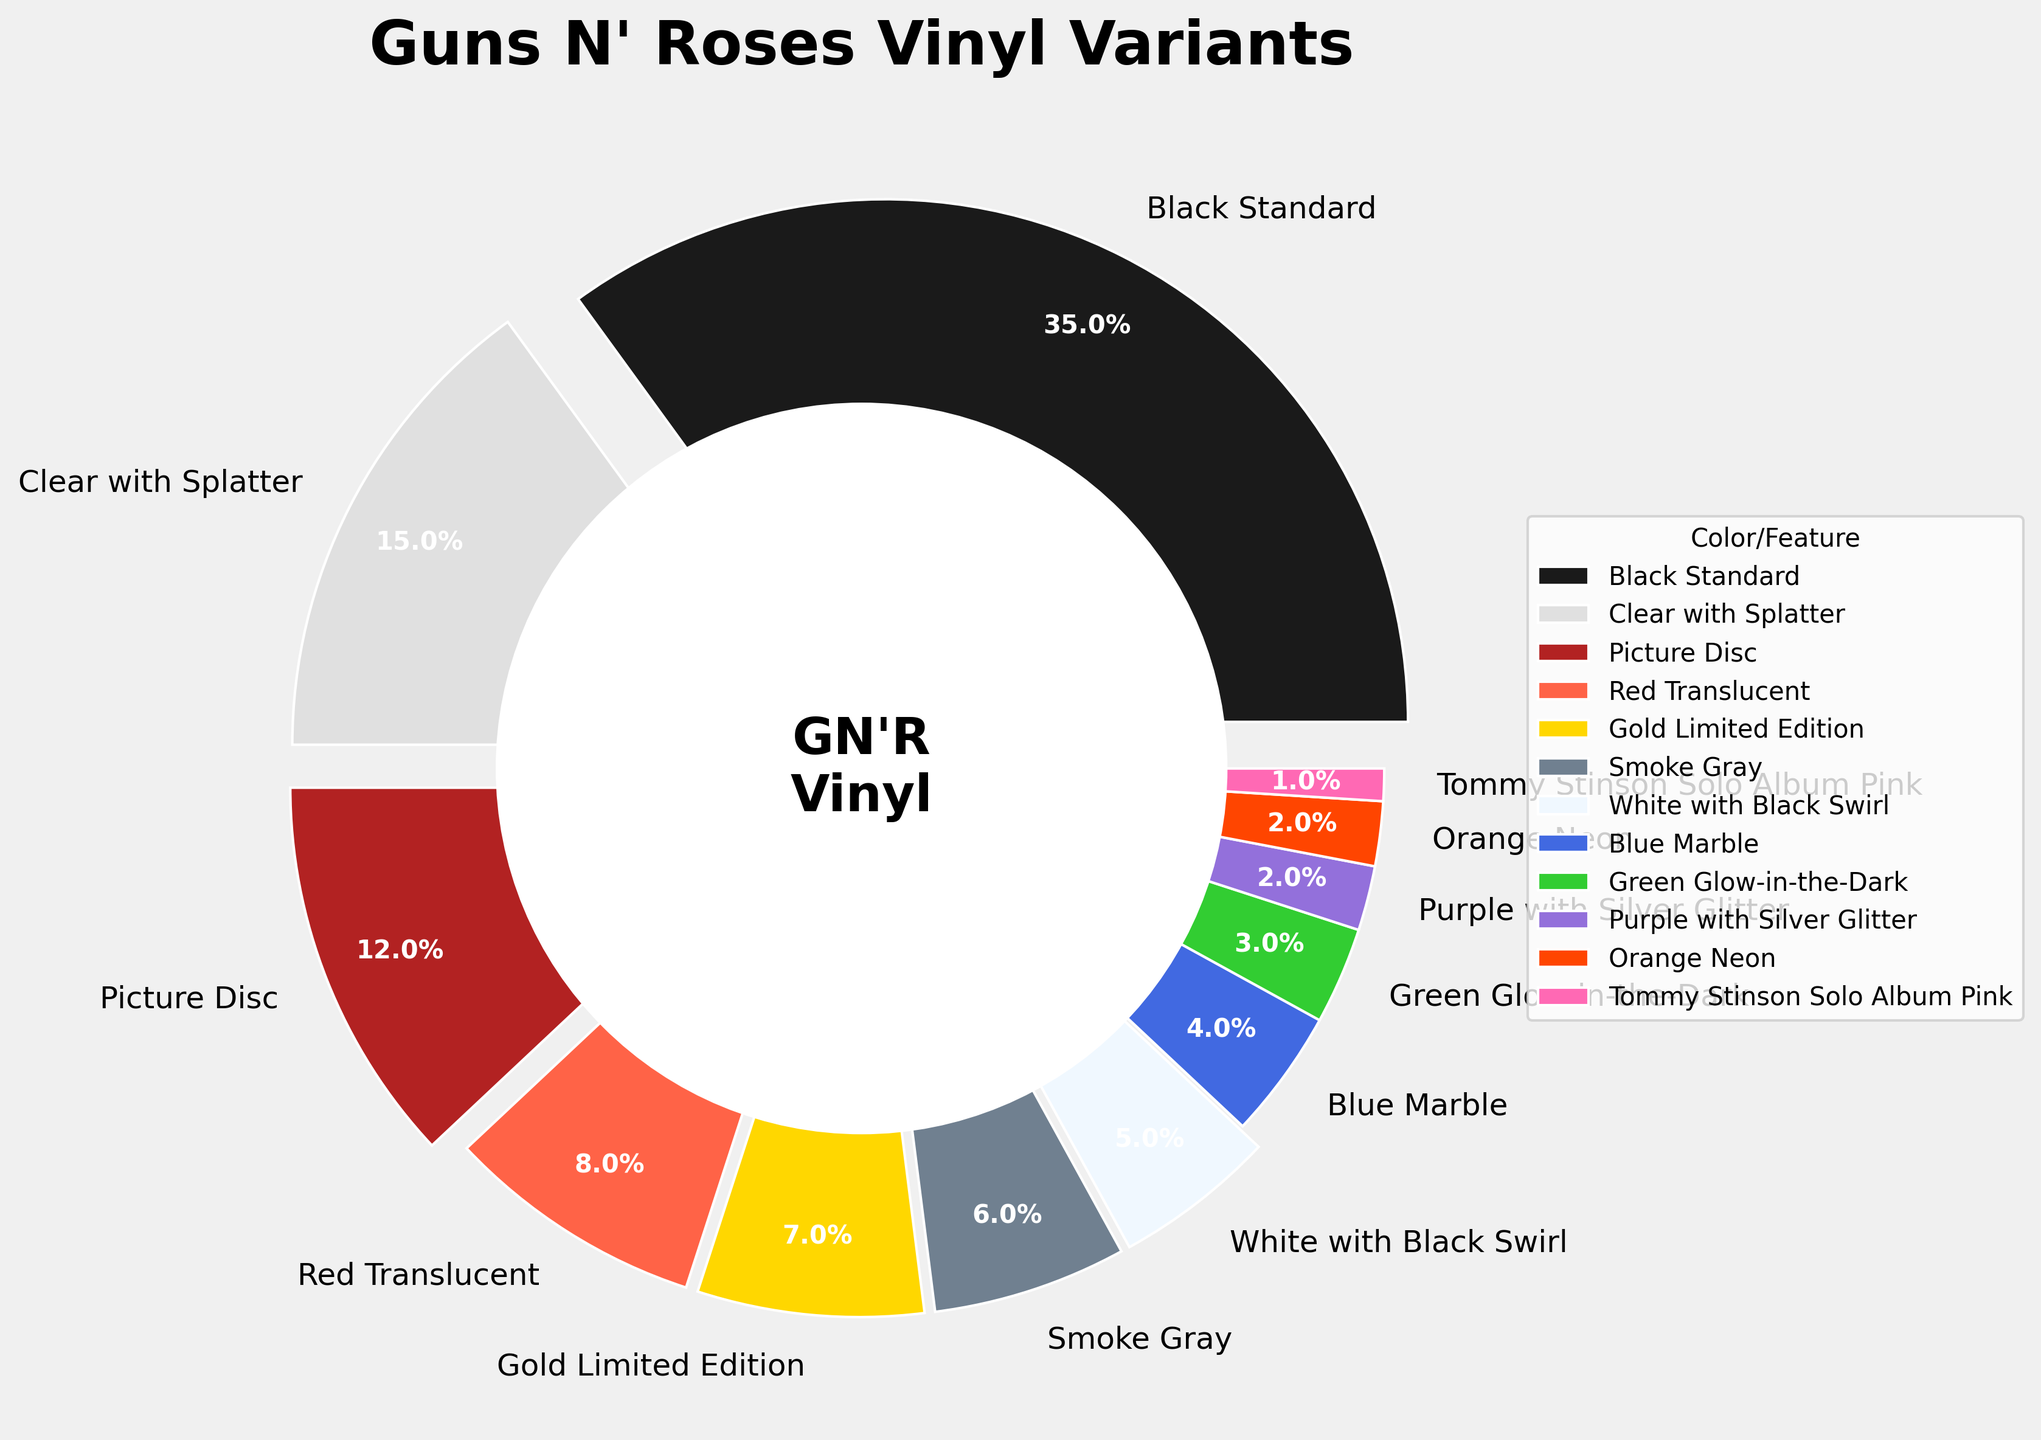What percentage of the vinyl variants are either Black Standard or Clear with Splatter? To find the total percentage of these two categories, add the percentages of Black Standard (35%) and Clear with Splatter (15%). So, 35 + 15 = 50%.
Answer: 50% Which color/feature variant has the smallest percentage? To determine the smallest percentage, look for the vinyl variant with the lowest value in the pie chart. Here, it is the Tommy Stinson Solo Album Pink at 1%.
Answer: Tommy Stinson Solo Album Pink How much more is the percentage of Black Standard compared to Smoke Gray? Subtract the percentage of Smoke Gray (6%) from the percentage of Black Standard (35%). So, 35 - 6 = 29%.
Answer: 29% What is the combined percentage of all variants with a feature or color related to red? Add the percentages for the categories related to red: Clear with Splatter (15%), Red Translucent (8%), and Picture Disc (12%). So, 15 + 8 + 12 = 35%.
Answer: 35% Which two color/feature variants are closest in percentage, and what are their values? To determine the closest in percentage, compare adjacent percentages from the chart. Blue Marble (4%) and Green Glow-in-the-Dark (3%) are closest, with a difference of only 1%.
Answer: Blue Marble (4%) and Green Glow-in-the-Dark (3%) Is the percentage of Picture Disc variants greater than the combined percentage of Green Glow-in-the-Dark and Orange Neon variants? Compare the percentages: Picture Disc (12%) vs. Green Glow-in-the-Dark (3%) + Orange Neon (2%) = 5%. Since 12% is greater than 5%, the answer is yes.
Answer: Yes What is the total percentage of vinyl variants that are less than or equal to 5% each? Add the percentages for categories that are 5% or lower: White with Black Swirl (5%), Blue Marble (4%), Green Glow-in-the-Dark (3%), Purple with Silver Glitter (2%), Orange Neon (2%), and Tommy Stinson Solo Album Pink (1%). So, 5 + 4 + 3 + 2 + 2 + 1 = 17%.
Answer: 17% What is the most common color/feature variant, and by what percent does it exceed the Gold Limited Edition variant? The most common variant is Black Standard (35%). To find the difference, subtract Gold Limited Edition's percentage (7%) from 35%. So, 35 - 7 = 28%.
Answer: Black Standard by 28% How does the percentage of Red Translucent compare to White with Black Swirl? Red Translucent is 8% and White with Black Swirl is 5%. Comparing them, 8% is greater than 5%.
Answer: Greater What is the sum of the percentages of all color/feature variants with special features (descriptive names)? Add the percentages of Clear with Splatter (15%), Picture Disc (12%), Gold Limited Edition (7%), White with Black Swirl (5%), Blue Marble (4%), Green Glow-in-the-Dark (3%), Purple with Silver Glitter (2%), and Orange Neon (2%). So, 15 + 12 + 7 + 5 + 4 + 3 + 2 + 2 = 50%.
Answer: 50% 